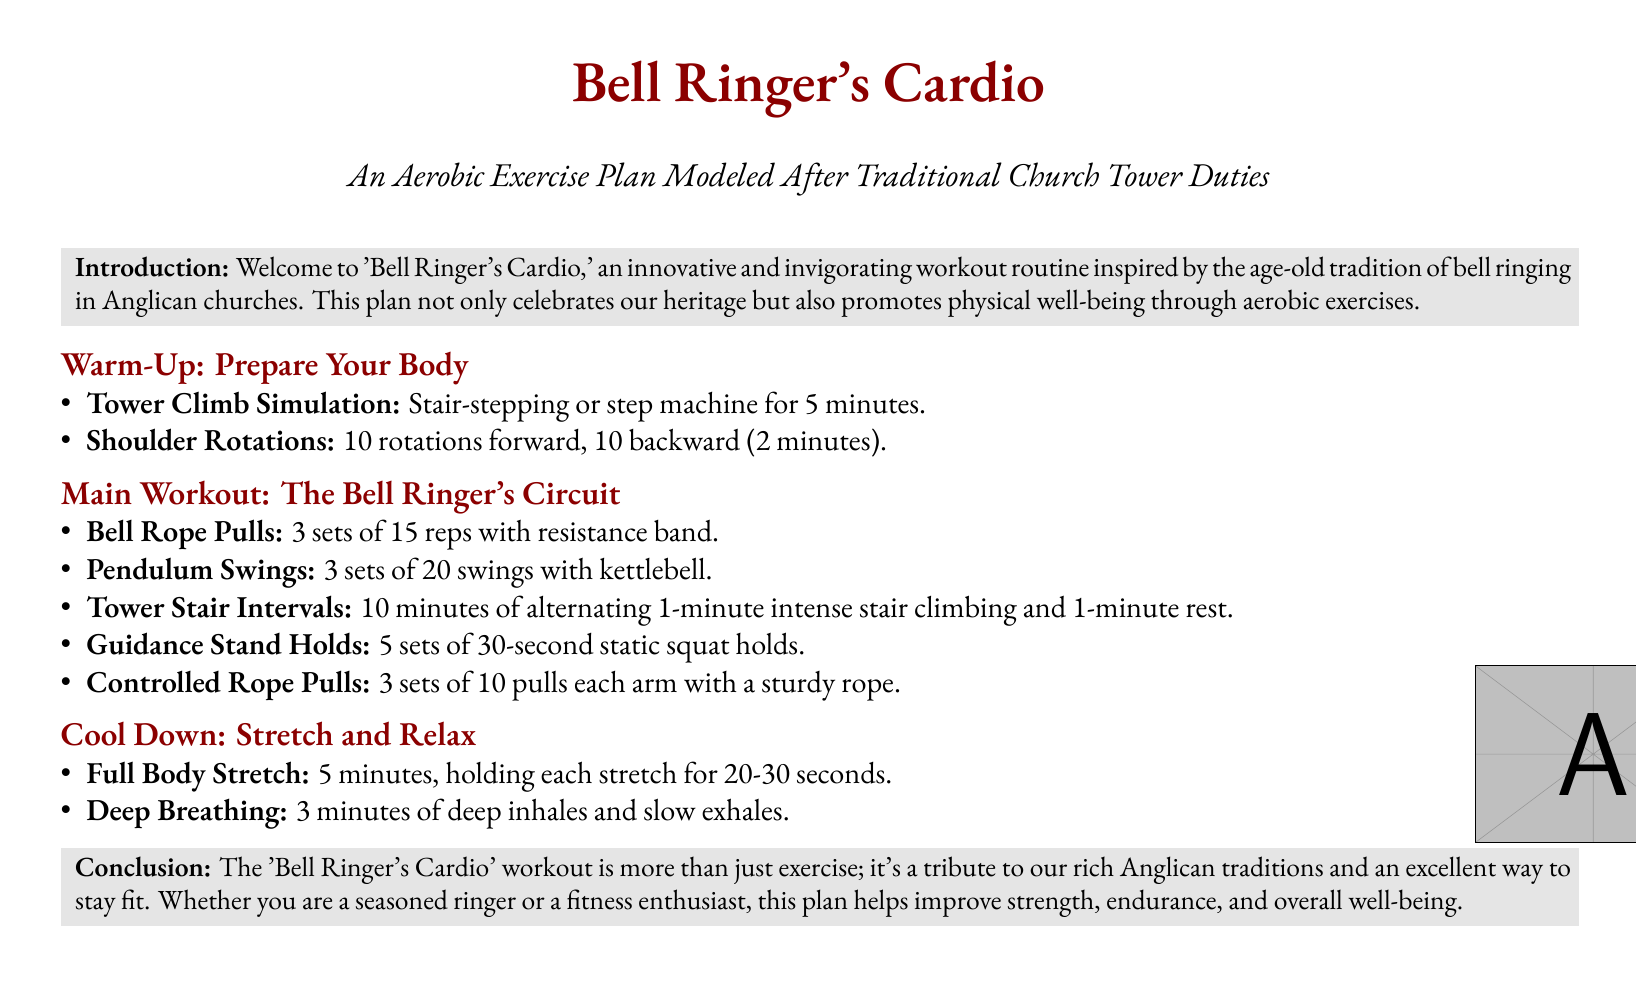What is the title of the workout plan? The title is prominently displayed at the beginning of the document.
Answer: Bell Ringer's Cardio How many sets are recommended for Bell Rope Pulls? The document specifies the number of sets in the main workout section.
Answer: 3 sets What is the duration of the full-body stretch? The duration is provided in the cool down section of the document.
Answer: 5 minutes How many shoulder rotations are suggested? The document details the repetitions in the warm-up section.
Answer: 10 rotations forward, 10 backward What type of exercise are Pendulum Swings performed with? The document mentions the equipment used in the main workout section.
Answer: Kettlebell What is the limit for the intensity periods in Tower Stair Intervals? The intensity is specified in the description of this workout segment.
Answer: 1 minute What breathing technique is included in the cool down? The document describes relaxation methods included.
Answer: Deep Breathing Is 'Bell Ringer's Cardio' intended for beginners or experienced individuals? The conclusion highlights the plan's accessibility.
Answer: Both 